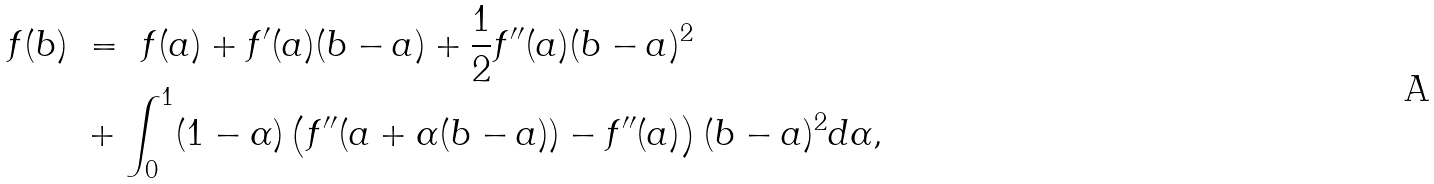Convert formula to latex. <formula><loc_0><loc_0><loc_500><loc_500>f ( b ) \ & = \ f ( a ) + f ^ { \prime } ( a ) ( b - a ) + \frac { 1 } { 2 } f ^ { \prime \prime } ( a ) ( b - a ) ^ { 2 } \\ & + \int _ { 0 } ^ { 1 } ( 1 - \alpha ) \left ( f ^ { \prime \prime } ( a + \alpha ( b - a ) ) - f ^ { \prime \prime } ( a ) \right ) ( b - a ) ^ { 2 } d \alpha ,</formula> 